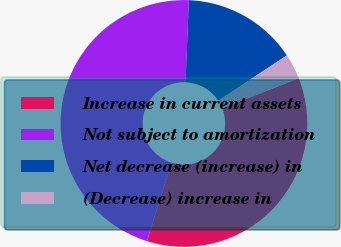<chart> <loc_0><loc_0><loc_500><loc_500><pie_chart><fcel>Increase in current assets<fcel>Not subject to amortization<fcel>Net decrease (increase) in<fcel>(Decrease) increase in<nl><fcel>35.81%<fcel>45.79%<fcel>15.07%<fcel>3.33%<nl></chart> 